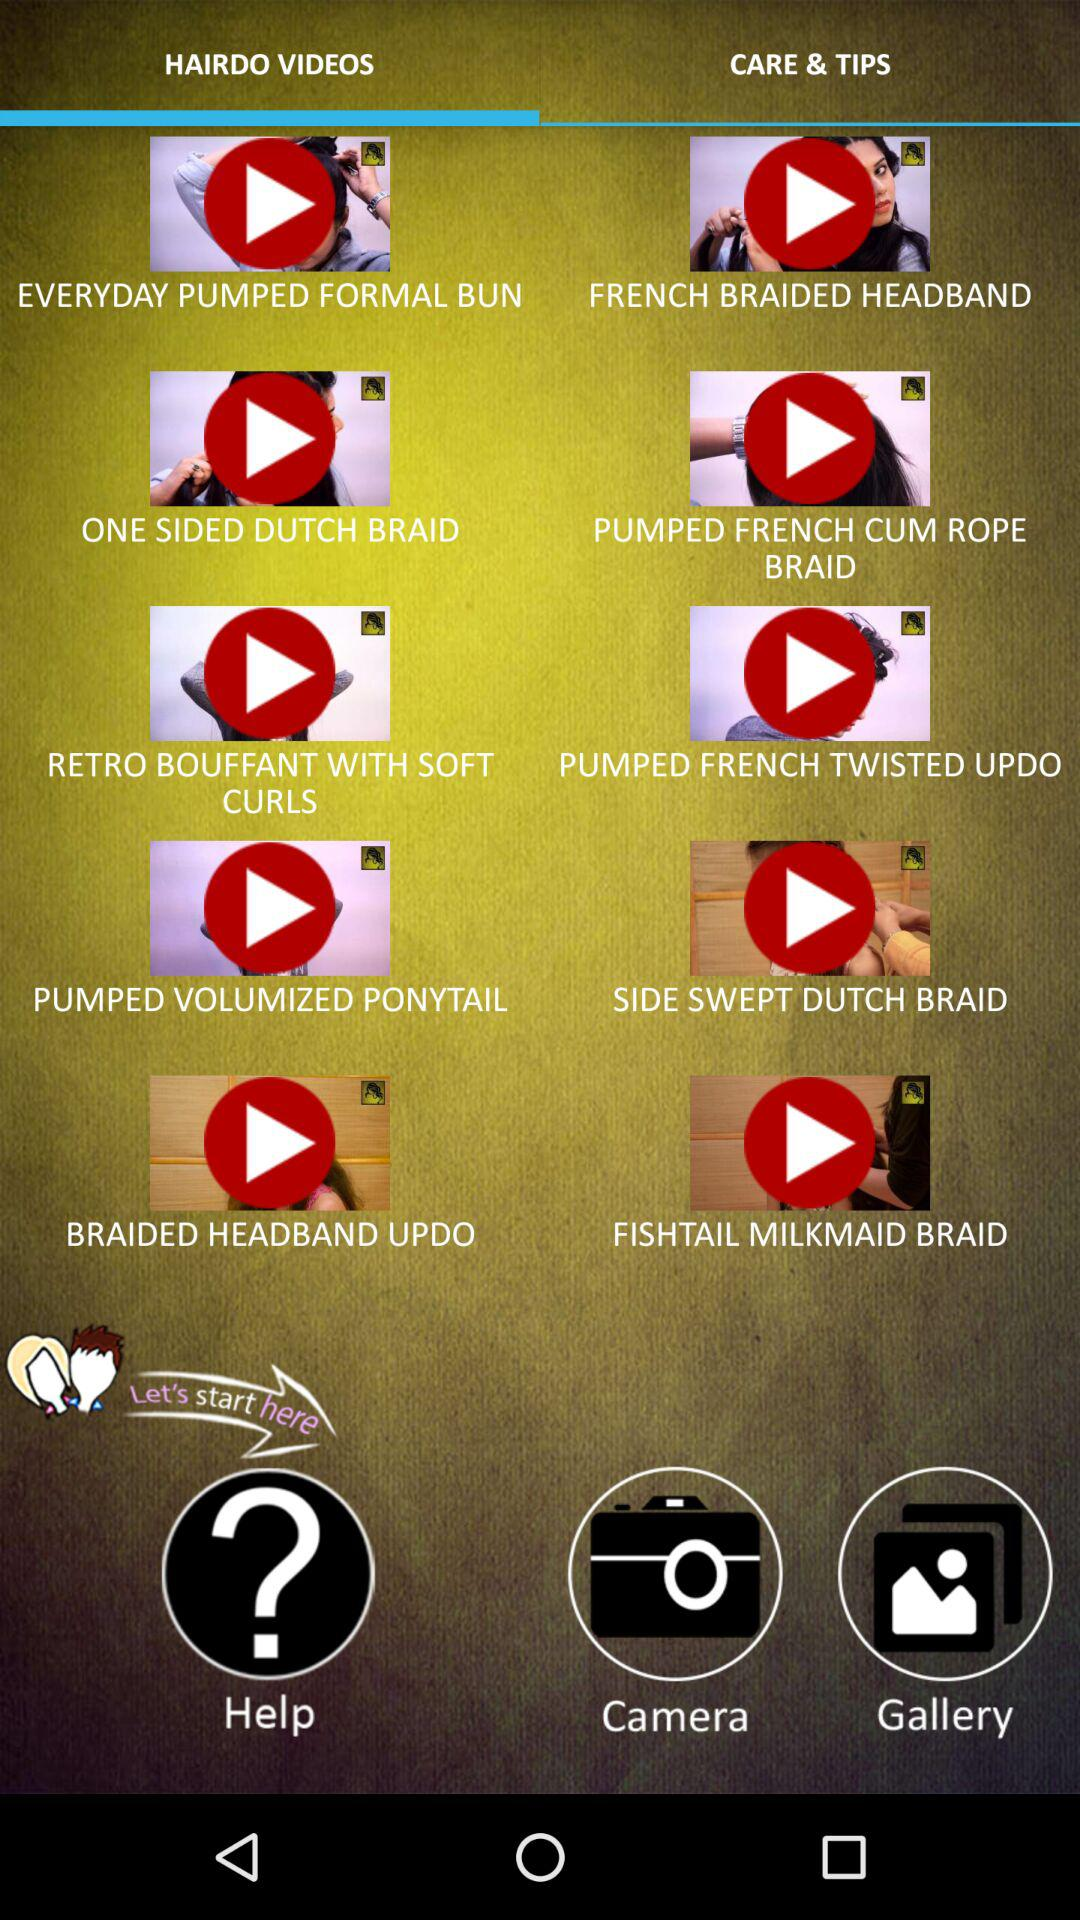Which tab is selected? The selected tab is "HAIRDO VIDEOS". 